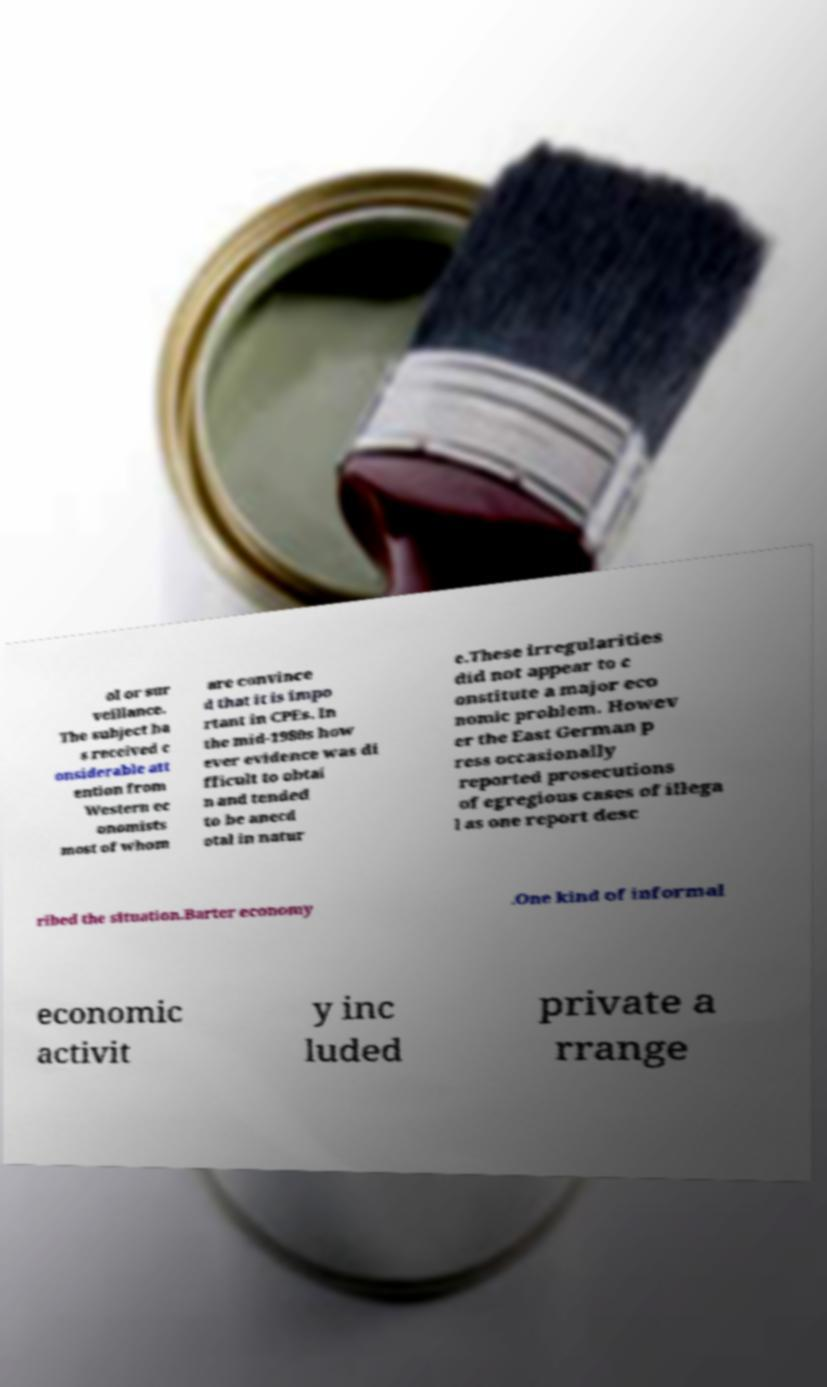Could you assist in decoding the text presented in this image and type it out clearly? ol or sur veillance. The subject ha s received c onsiderable att ention from Western ec onomists most of whom are convince d that it is impo rtant in CPEs. In the mid-1980s how ever evidence was di fficult to obtai n and tended to be anecd otal in natur e.These irregularities did not appear to c onstitute a major eco nomic problem. Howev er the East German p ress occasionally reported prosecutions of egregious cases of illega l as one report desc ribed the situation.Barter economy .One kind of informal economic activit y inc luded private a rrange 